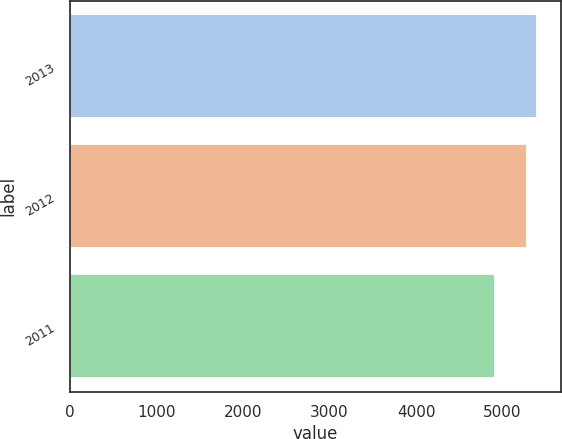Convert chart to OTSL. <chart><loc_0><loc_0><loc_500><loc_500><bar_chart><fcel>2013<fcel>2012<fcel>2011<nl><fcel>5401<fcel>5282<fcel>4911<nl></chart> 